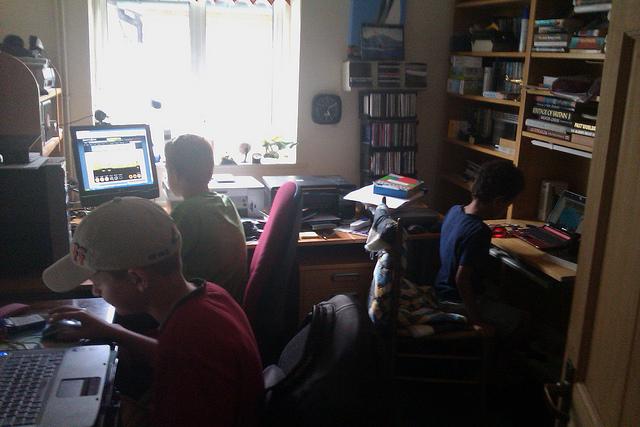Is anyone using an iPad?
Short answer required. No. Where is the calendar located in this picture?
Answer briefly. Wall. What color are the chairs?
Concise answer only. Red and gray. Is there natural light in the room?
Short answer required. Yes. How many people are in the photo?
Give a very brief answer. 3. How many books are in the background on the table?
Write a very short answer. 1. What is the photographer wearing?
Be succinct. Hat. Could this be a "home-school"?
Short answer required. Yes. 